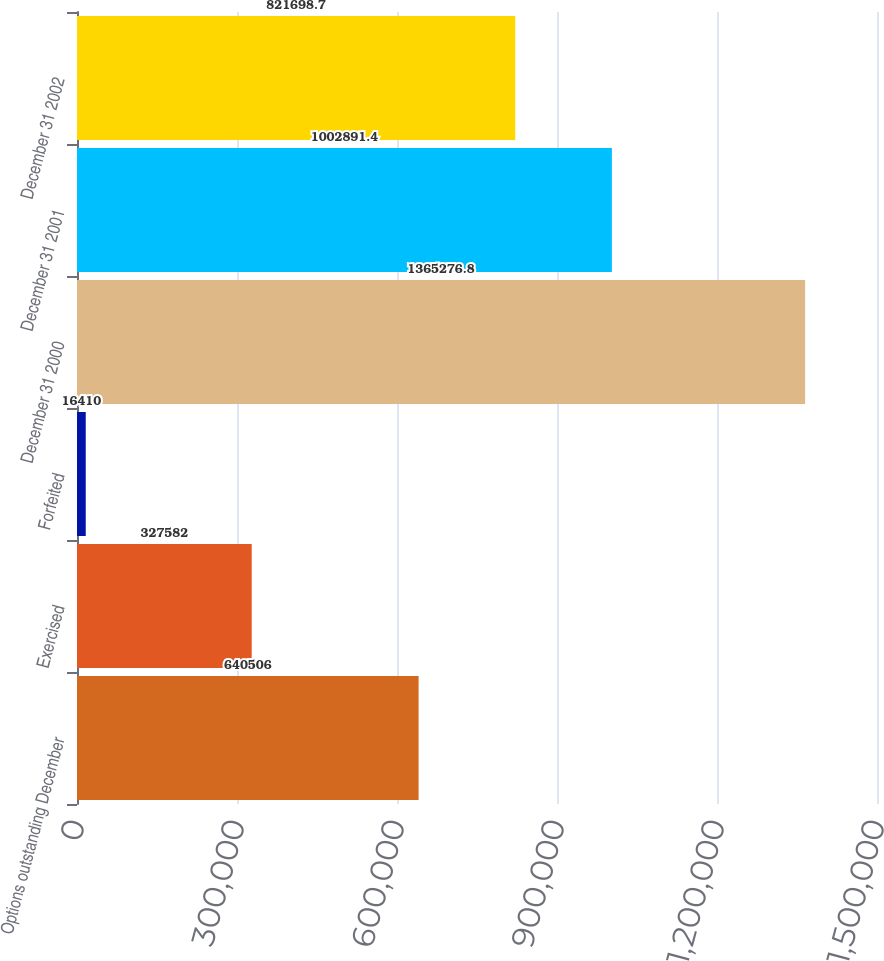Convert chart. <chart><loc_0><loc_0><loc_500><loc_500><bar_chart><fcel>Options outstanding December<fcel>Exercised<fcel>Forfeited<fcel>December 31 2000<fcel>December 31 2001<fcel>December 31 2002<nl><fcel>640506<fcel>327582<fcel>16410<fcel>1.36528e+06<fcel>1.00289e+06<fcel>821699<nl></chart> 